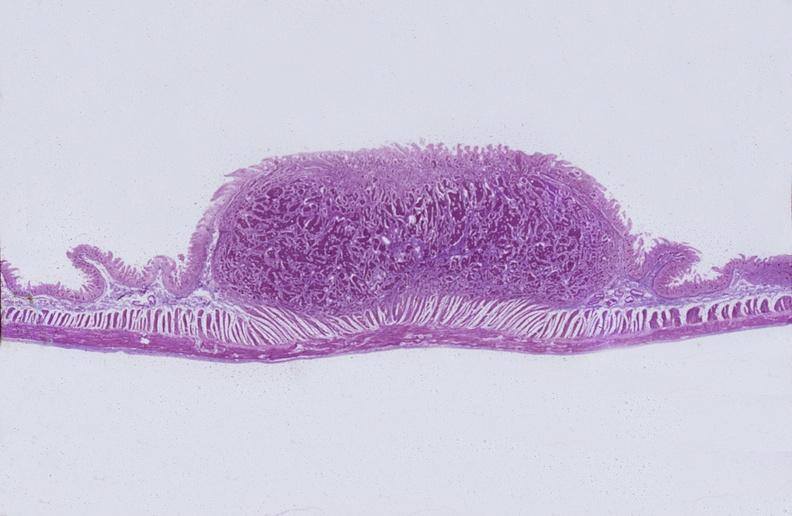s 70yof present?
Answer the question using a single word or phrase. No 